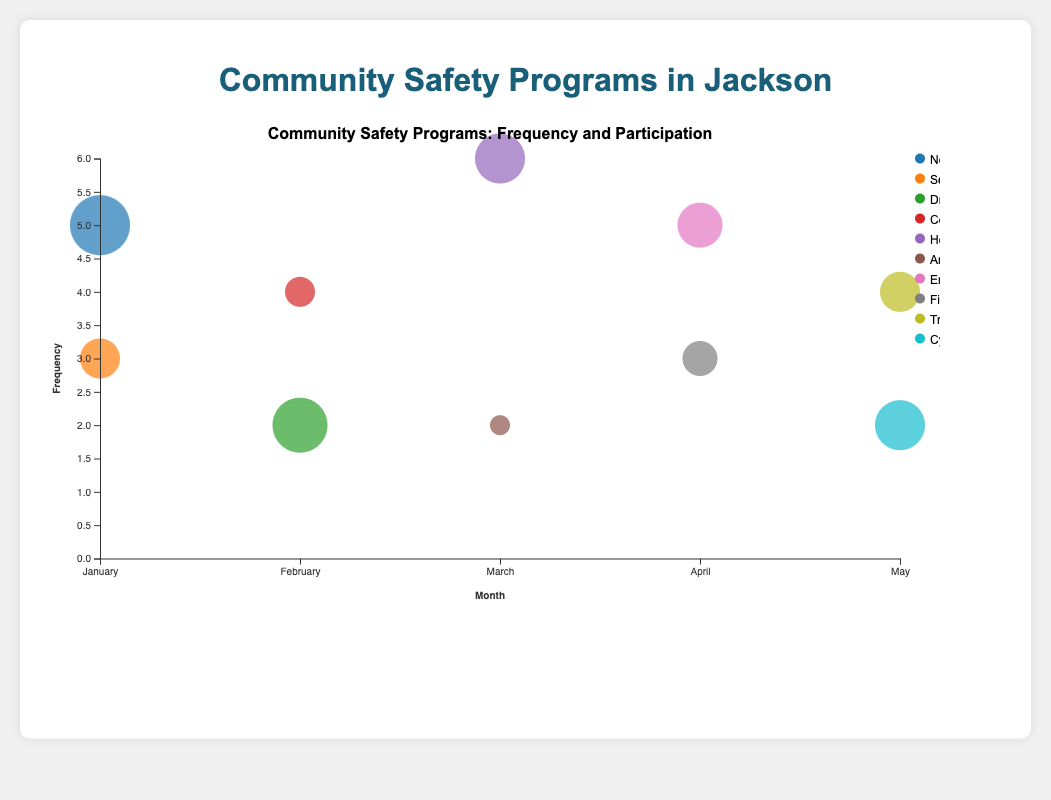How many different Community Safety Programs are represented in the chart? Observe the unique names of the programs in the legend, which list distinct Community Safety Programs.
Answer: 10 Which month has the highest frequency of community safety programs overall? January has points representing the highest frequencies summed up, which are 5 (Neighborhood Watch Meetings) and 3 (Self-Defense Workshops), totaling 8.
Answer: January Which program in April has a higher participation rate, and what is it? Compare the sizes of the circles in April. The Emergency Preparedness Drills have a larger circle than Fire Safety Seminars; their participation rates are 35% and 25% respectively.
Answer: Emergency Preparedness Drills, 35% How does the participation rate of Home Safety Evaluations in March compare to Cyber Safety Workshops in May? Compare the sizes of the circles. Home Safety Evaluations (40%) in March has a slightly larger circle than Cyber Safety Workshops (40%) in May, indicating they have the same participation rate.
Answer: Equal, 40% What is the average frequency of programs held in February? Sum the frequencies in February (2 for Drug Awareness Seminars and 4 for Community Patrol Training) and divide by the number of programs (2). Calculation: (2+4)/2 = 3.
Answer: 3 Which program has the smallest participation rate, and what is it? Identify the smallest circle in terms of size on the chart, which corresponds to Anti-Bullying Workshops in March with a 10% participation rate.
Answer: Anti-Bullying Workshops, 10% Which program has the highest frequency in March, and how big is its participation rate? Identify the highest point in March and check its corresponding program and circle size. Home Safety Evaluations have the highest frequency (6) and a participation rate of 40%.
Answer: Home Safety Evaluations, 40% How many community safety programs have a participation rate of 30%? Identify circles that represent a 30% participation rate, which occur for the Self-Defense Workshops in January and Traffic Safety Education in May.
Answer: 2 